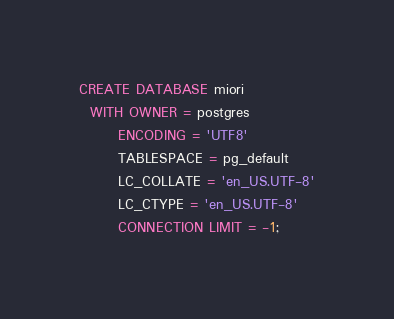<code> <loc_0><loc_0><loc_500><loc_500><_SQL_>CREATE DATABASE miori
  WITH OWNER = postgres
       ENCODING = 'UTF8'
       TABLESPACE = pg_default
       LC_COLLATE = 'en_US.UTF-8'
       LC_CTYPE = 'en_US.UTF-8'
       CONNECTION LIMIT = -1;

</code> 